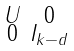Convert formula to latex. <formula><loc_0><loc_0><loc_500><loc_500>\begin{smallmatrix} U & 0 \\ 0 & I _ { k - d } \end{smallmatrix}</formula> 